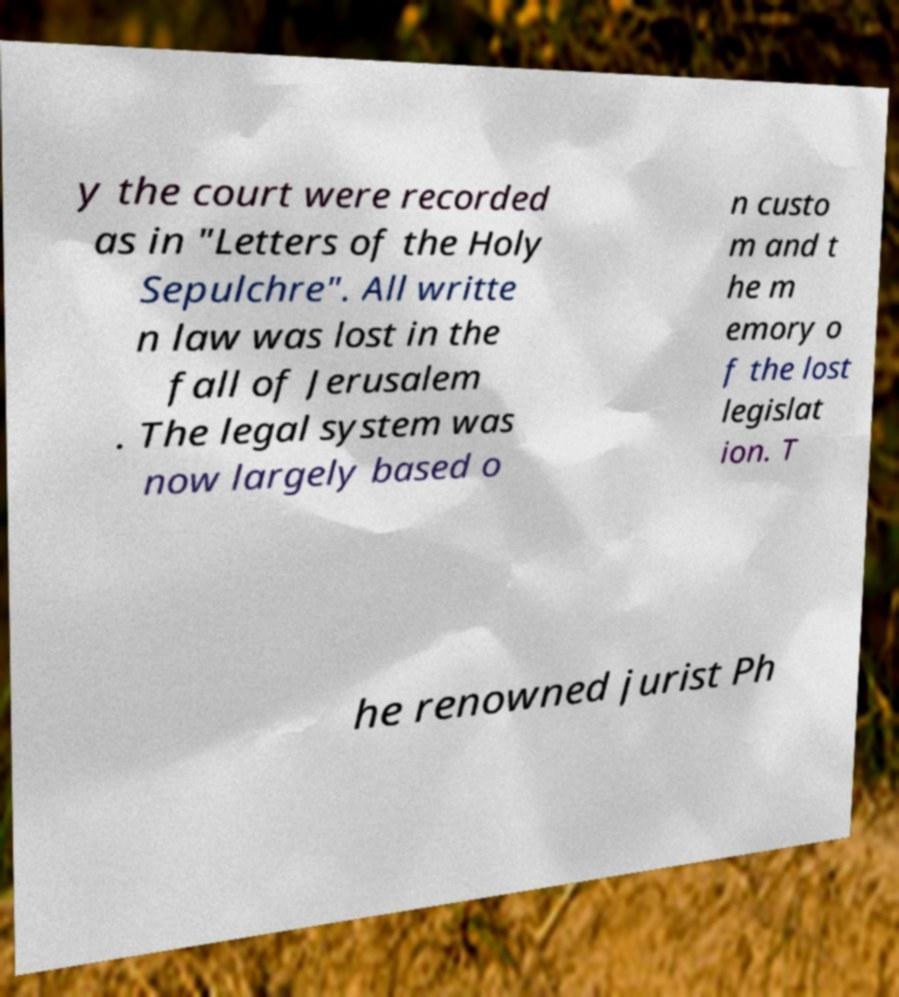There's text embedded in this image that I need extracted. Can you transcribe it verbatim? y the court were recorded as in "Letters of the Holy Sepulchre". All writte n law was lost in the fall of Jerusalem . The legal system was now largely based o n custo m and t he m emory o f the lost legislat ion. T he renowned jurist Ph 